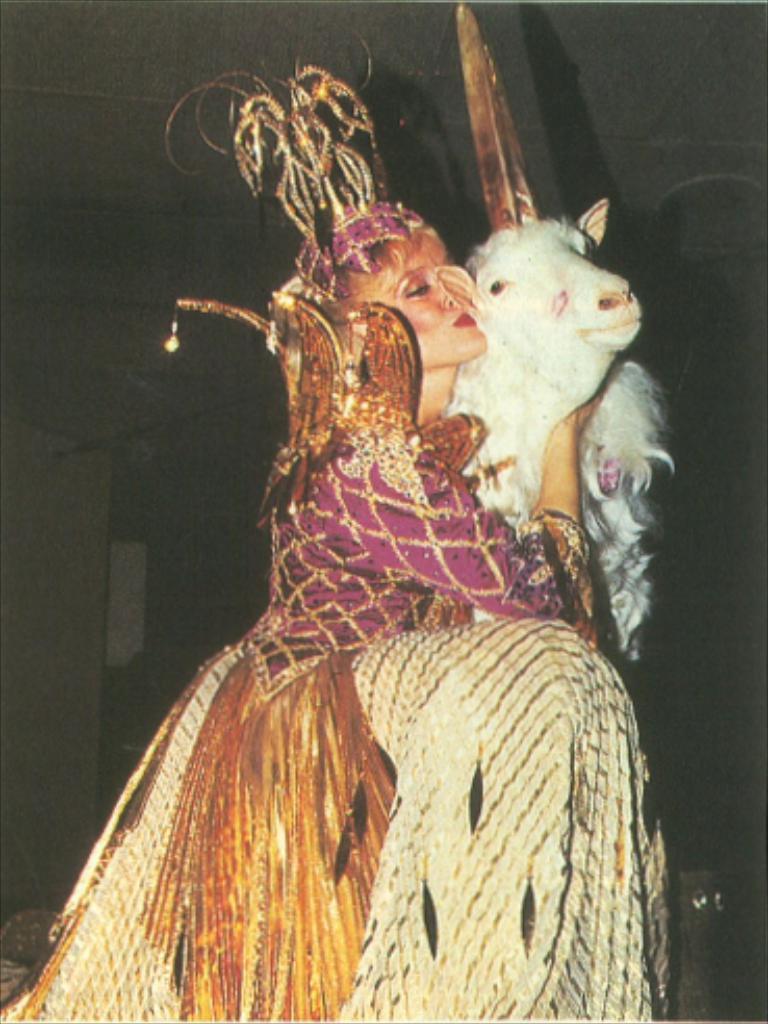Describe this image in one or two sentences. In this image in the center there is one woman who is wearing some costume and she is holding a sheep, and in the background there are some objects. At the top of there is ceiling. 